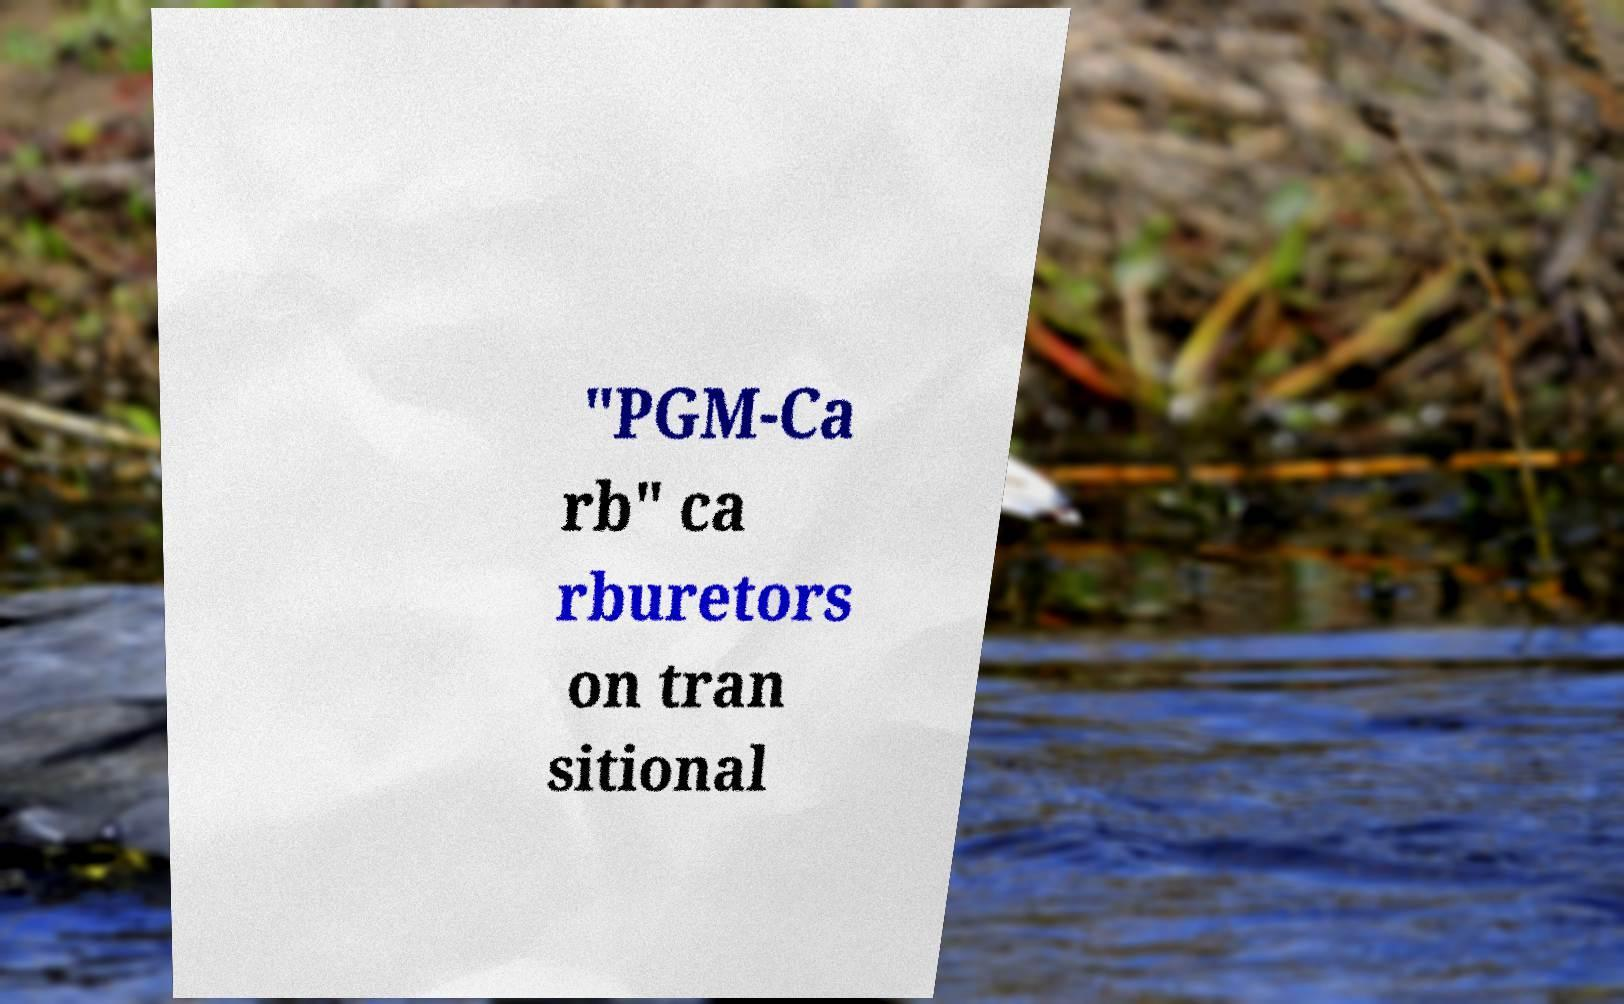Could you assist in decoding the text presented in this image and type it out clearly? "PGM-Ca rb" ca rburetors on tran sitional 